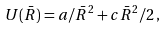Convert formula to latex. <formula><loc_0><loc_0><loc_500><loc_500>U ( \bar { R } ) = a / \bar { R } ^ { 2 } + c \bar { R } ^ { 2 } / 2 \, ,</formula> 